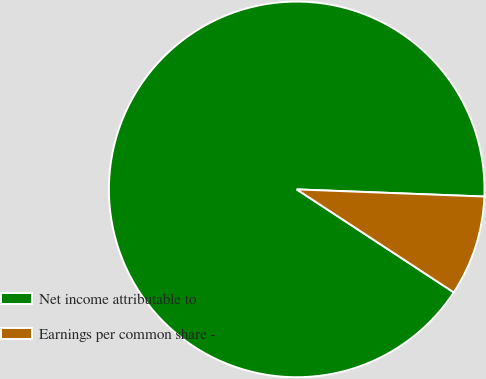Convert chart to OTSL. <chart><loc_0><loc_0><loc_500><loc_500><pie_chart><fcel>Net income attributable to<fcel>Earnings per common share -<nl><fcel>91.37%<fcel>8.63%<nl></chart> 